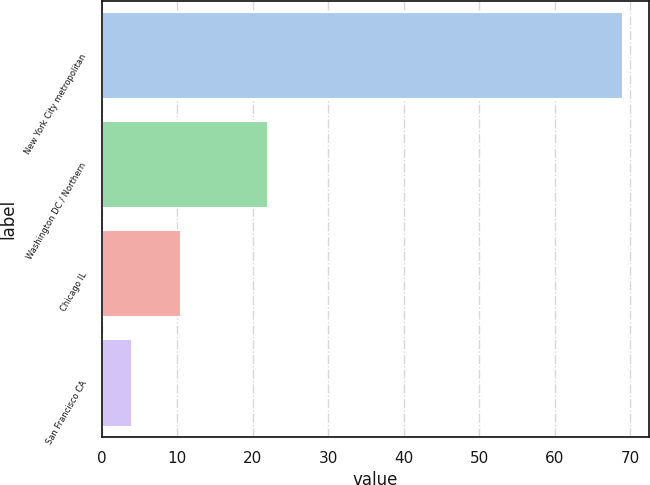Convert chart. <chart><loc_0><loc_0><loc_500><loc_500><bar_chart><fcel>New York City metropolitan<fcel>Washington DC / Northern<fcel>Chicago IL<fcel>San Francisco CA<nl><fcel>69<fcel>22<fcel>10.5<fcel>4<nl></chart> 